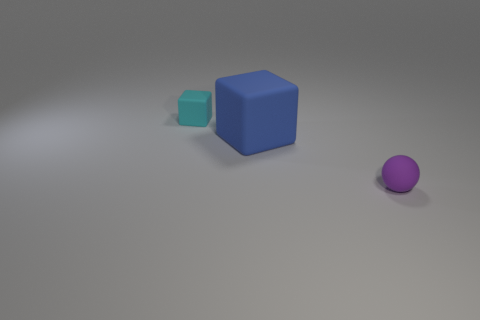Is there anything else that has the same material as the cyan thing?
Make the answer very short. Yes. There is a purple sphere that is the same size as the cyan matte thing; what is its material?
Give a very brief answer. Rubber. What is the color of the matte cube that is the same size as the ball?
Your answer should be compact. Cyan. There is a matte cube that is behind the big blue matte cube; is its size the same as the cube on the right side of the small cyan rubber thing?
Offer a terse response. No. There is a matte block in front of the small object on the left side of the tiny purple matte ball right of the blue block; how big is it?
Keep it short and to the point. Large. What is the shape of the tiny matte thing that is left of the tiny matte thing that is on the right side of the tiny cyan matte block?
Offer a very short reply. Cube. There is a small object to the left of the tiny purple object; does it have the same color as the sphere?
Provide a short and direct response. No. There is a matte object that is both in front of the cyan cube and left of the tiny rubber ball; what color is it?
Ensure brevity in your answer.  Blue. Is there another cyan cube that has the same material as the tiny cyan cube?
Offer a very short reply. No. What is the size of the blue matte cube?
Your answer should be very brief. Large. 